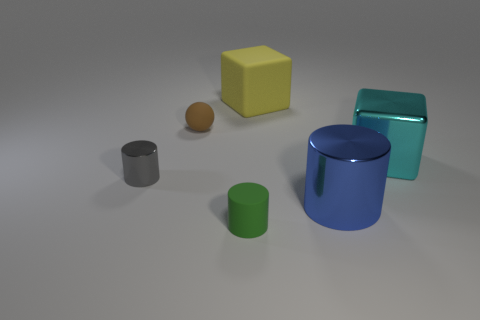How many large objects are the same color as the rubber cylinder?
Your answer should be very brief. 0. What size is the cylinder that is in front of the small gray metallic thing and on the left side of the blue cylinder?
Your answer should be compact. Small. Is the number of small metal cylinders that are behind the brown sphere less than the number of cylinders?
Provide a short and direct response. Yes. Is the tiny gray cylinder made of the same material as the big blue cylinder?
Provide a succinct answer. Yes. How many objects are large matte objects or tiny shiny cylinders?
Make the answer very short. 2. How many cyan things are made of the same material as the small green thing?
Your answer should be compact. 0. There is a gray thing that is the same shape as the tiny green rubber object; what size is it?
Give a very brief answer. Small. There is a brown sphere; are there any big yellow rubber cubes to the right of it?
Offer a terse response. Yes. What is the material of the small green cylinder?
Keep it short and to the point. Rubber. There is a matte thing in front of the tiny gray cylinder; is its color the same as the ball?
Your response must be concise. No. 